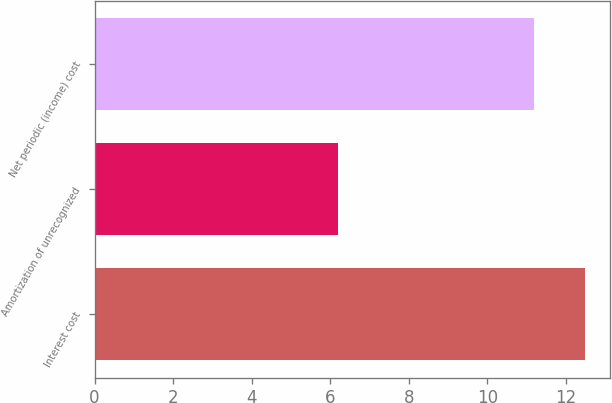<chart> <loc_0><loc_0><loc_500><loc_500><bar_chart><fcel>Interest cost<fcel>Amortization of unrecognized<fcel>Net periodic (income) cost<nl><fcel>12.5<fcel>6.2<fcel>11.2<nl></chart> 